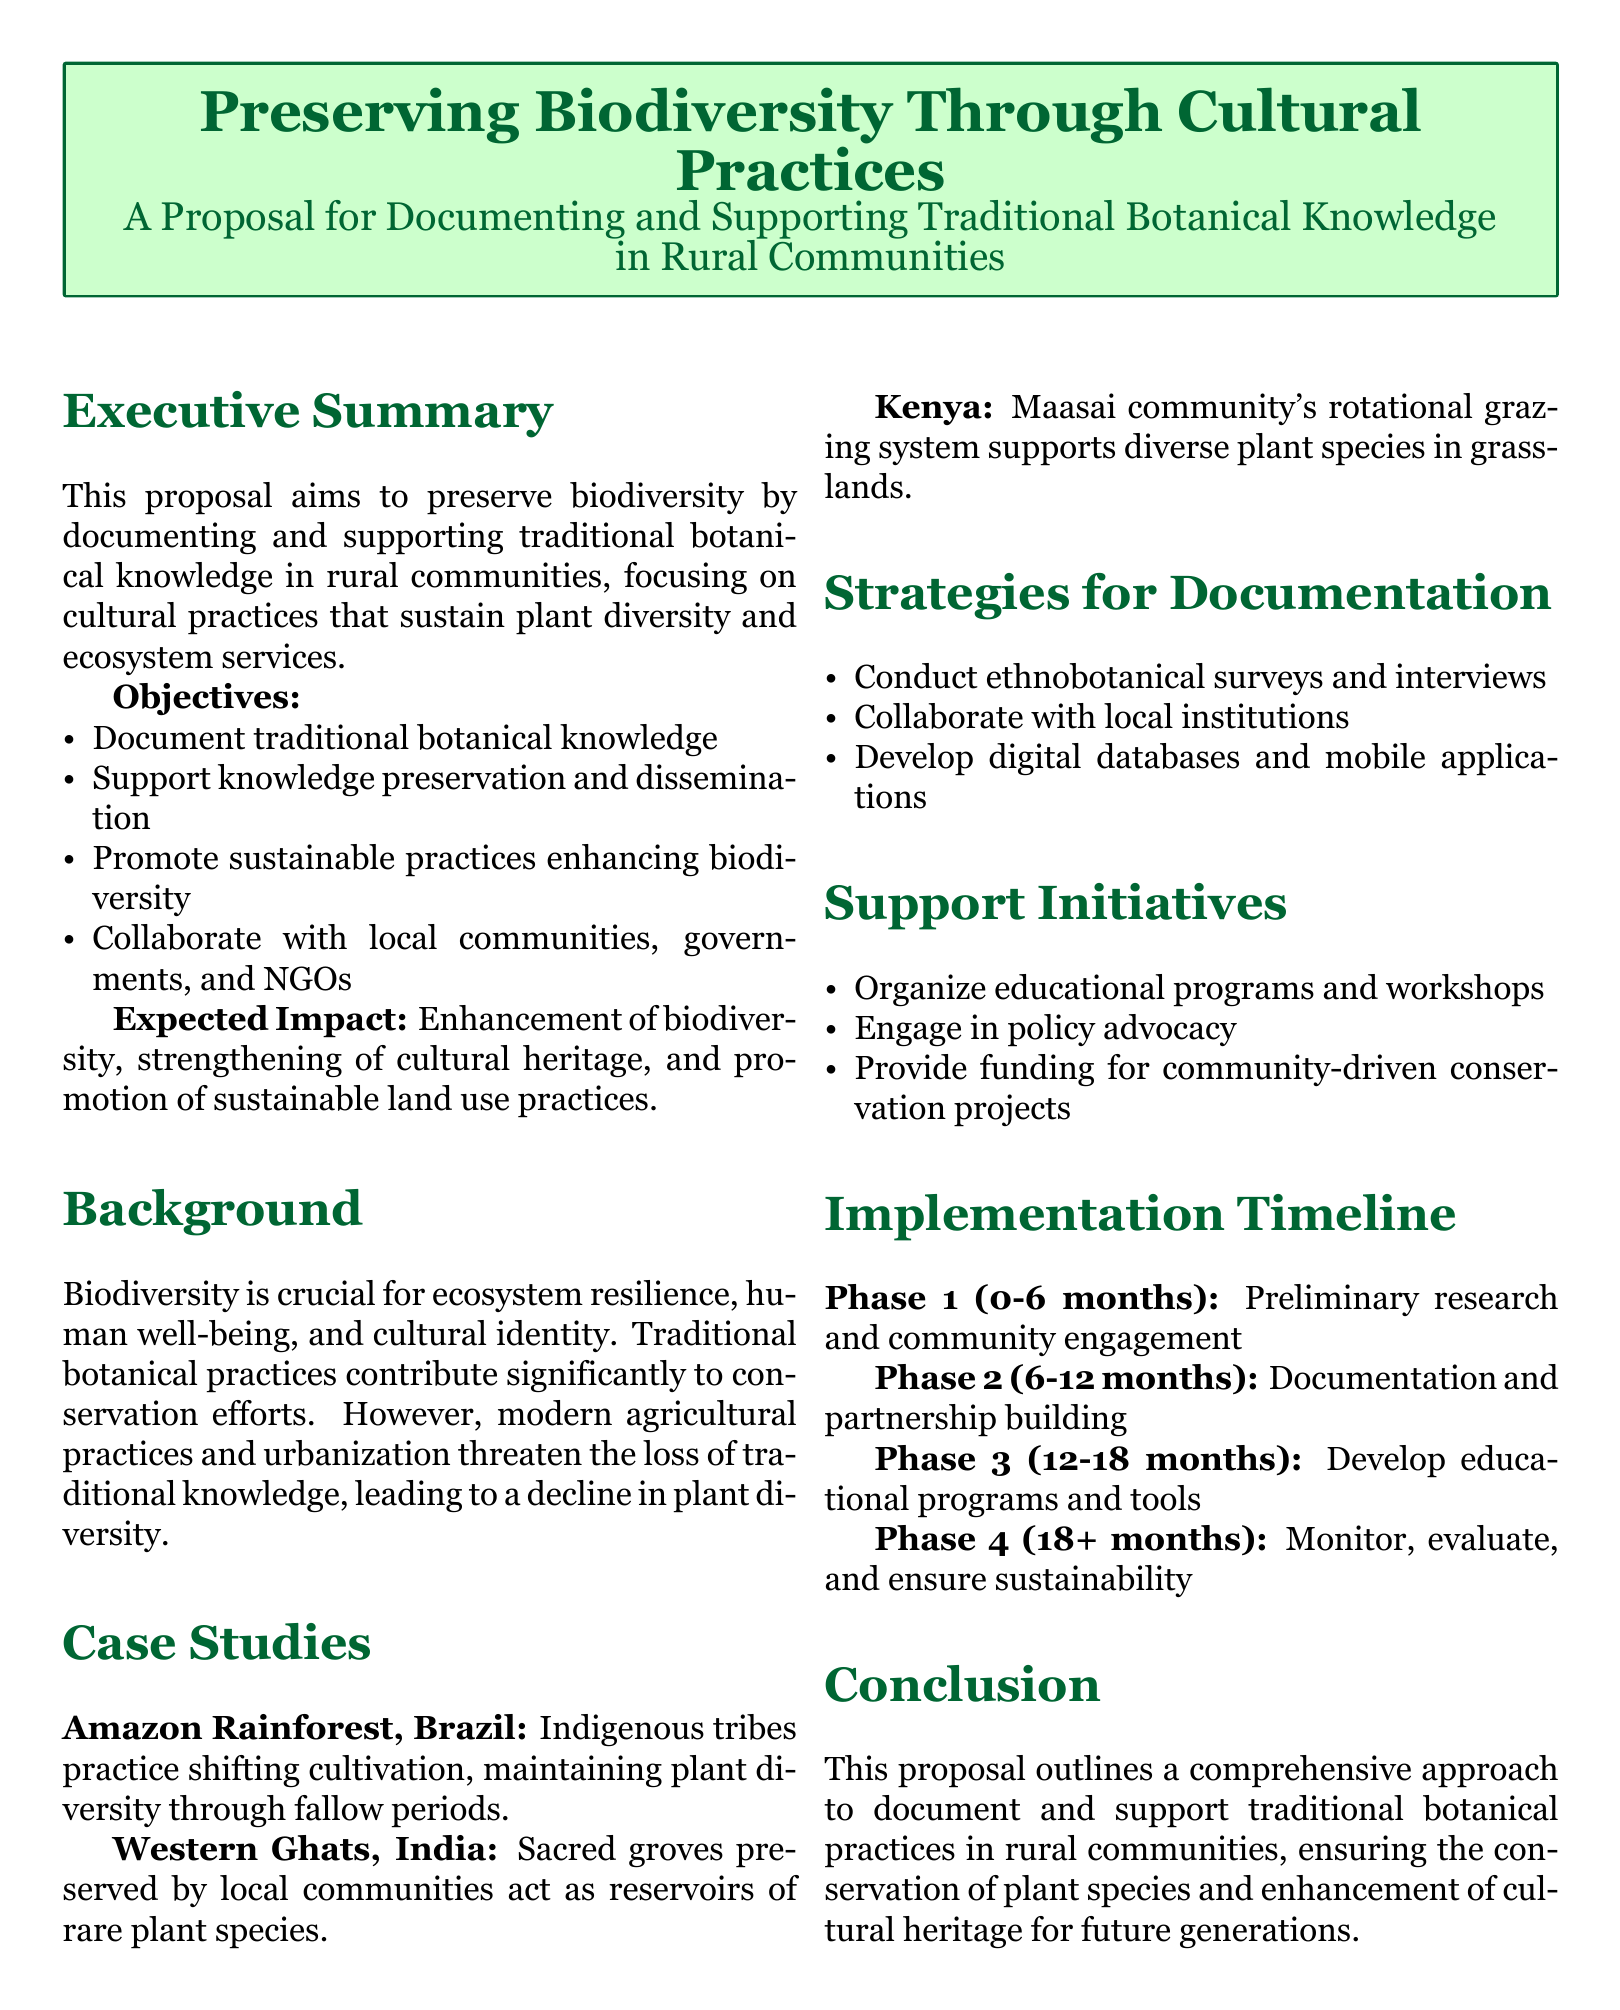What is the main goal of the proposal? The main goal of the proposal is to preserve biodiversity through documenting and supporting traditional botanical knowledge in rural communities.
Answer: Preserve biodiversity What is one of the objectives mentioned in the proposal? One of the objectives mentioned is to document traditional botanical knowledge.
Answer: Document traditional botanical knowledge What region is highlighted in the case study related to Indigenous tribes? The Amazon Rainforest in Brazil is highlighted in the case study.
Answer: Amazon Rainforest, Brazil How long is Phase 1 of the implementation timeline? Phase 1 of the implementation timeline is 6 months long.
Answer: 6 months What type of practices are being promoted according to the expected impact? The proposal promotes sustainable practices.
Answer: Sustainable practices What is a method suggested for documentation in the strategies? Conduct ethnobotanical surveys and interviews is a suggested method.
Answer: Ethnobotanical surveys and interviews How many phases are outlined in the implementation timeline? There are four phases outlined in the implementation timeline.
Answer: Four phases Which community’s grazing system is mentioned as supporting diverse plant species? The Maasai community's grazing system is mentioned.
Answer: Maasai community What do the support initiatives include? Organizing educational programs and workshops is one of the initiatives.
Answer: Educational programs and workshops 